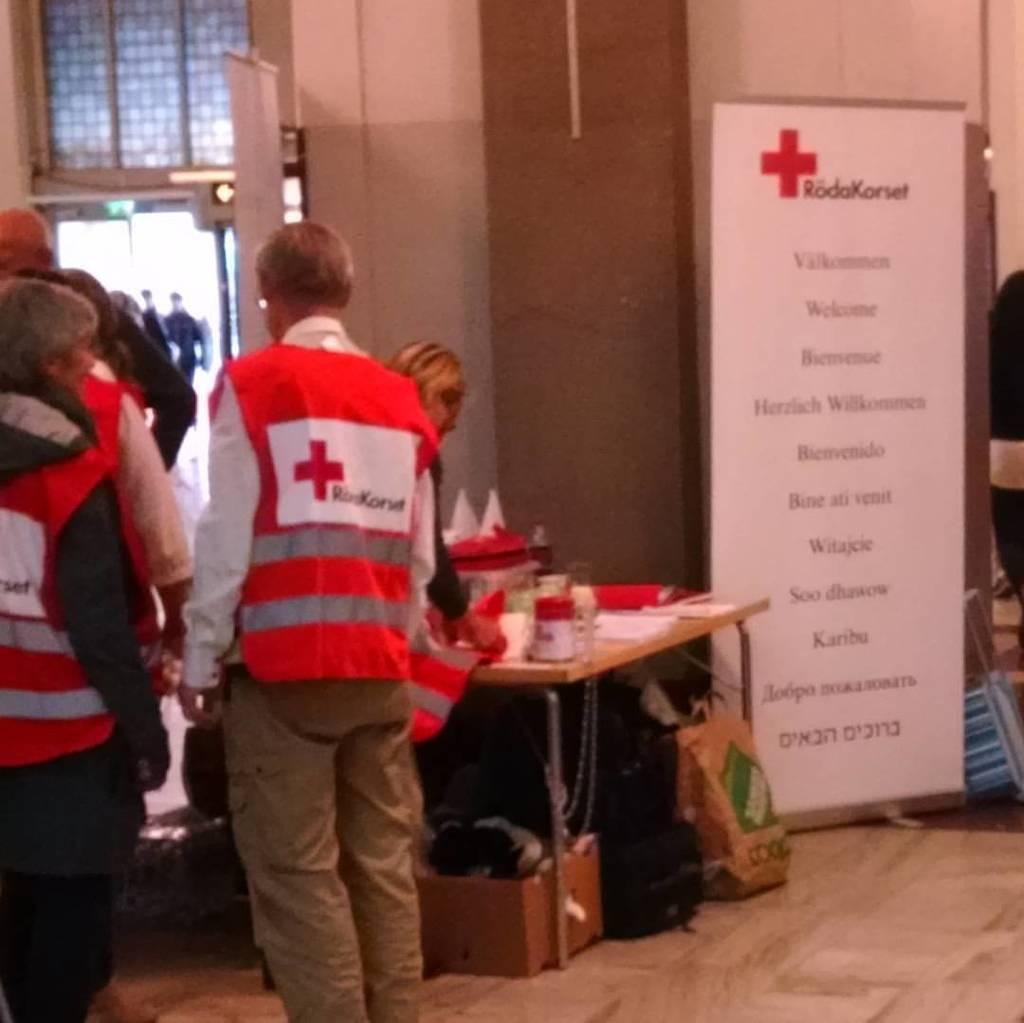Could you give a brief overview of what you see in this image? This is a table where a medical equipment is kept on it. There is a group of people who are standing. 